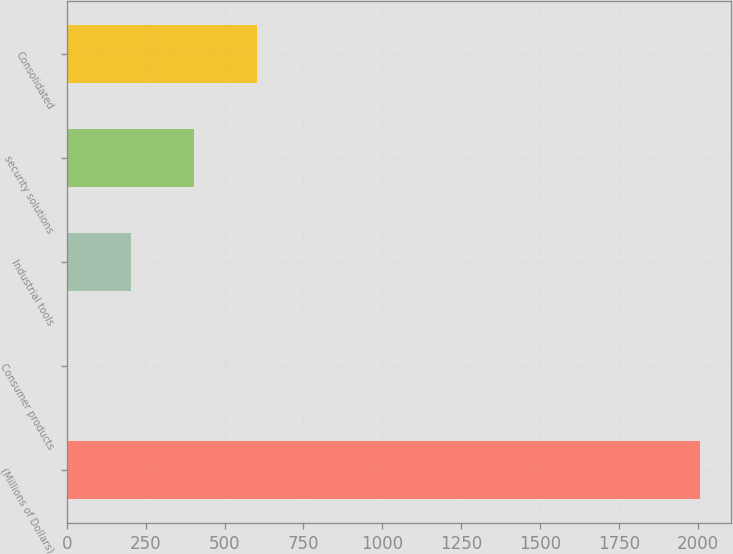Convert chart to OTSL. <chart><loc_0><loc_0><loc_500><loc_500><bar_chart><fcel>(Millions of Dollars)<fcel>Consumer products<fcel>Industrial tools<fcel>security solutions<fcel>Consolidated<nl><fcel>2005<fcel>3<fcel>203.2<fcel>403.4<fcel>603.6<nl></chart> 